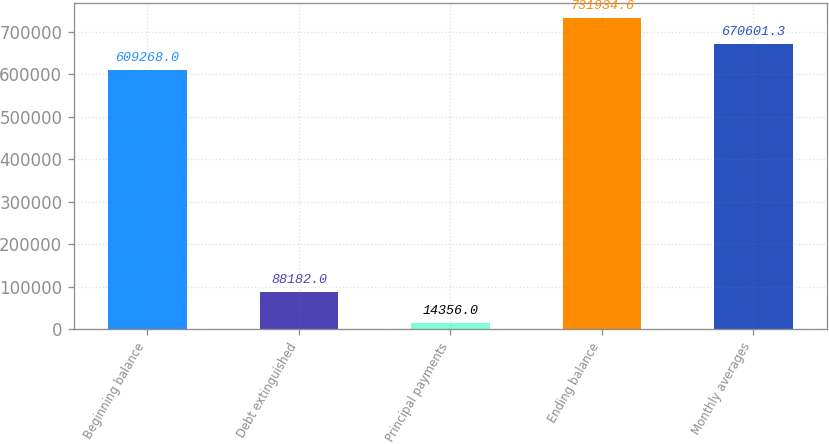Convert chart. <chart><loc_0><loc_0><loc_500><loc_500><bar_chart><fcel>Beginning balance<fcel>Debt extinguished<fcel>Principal payments<fcel>Ending balance<fcel>Monthly averages<nl><fcel>609268<fcel>88182<fcel>14356<fcel>731935<fcel>670601<nl></chart> 